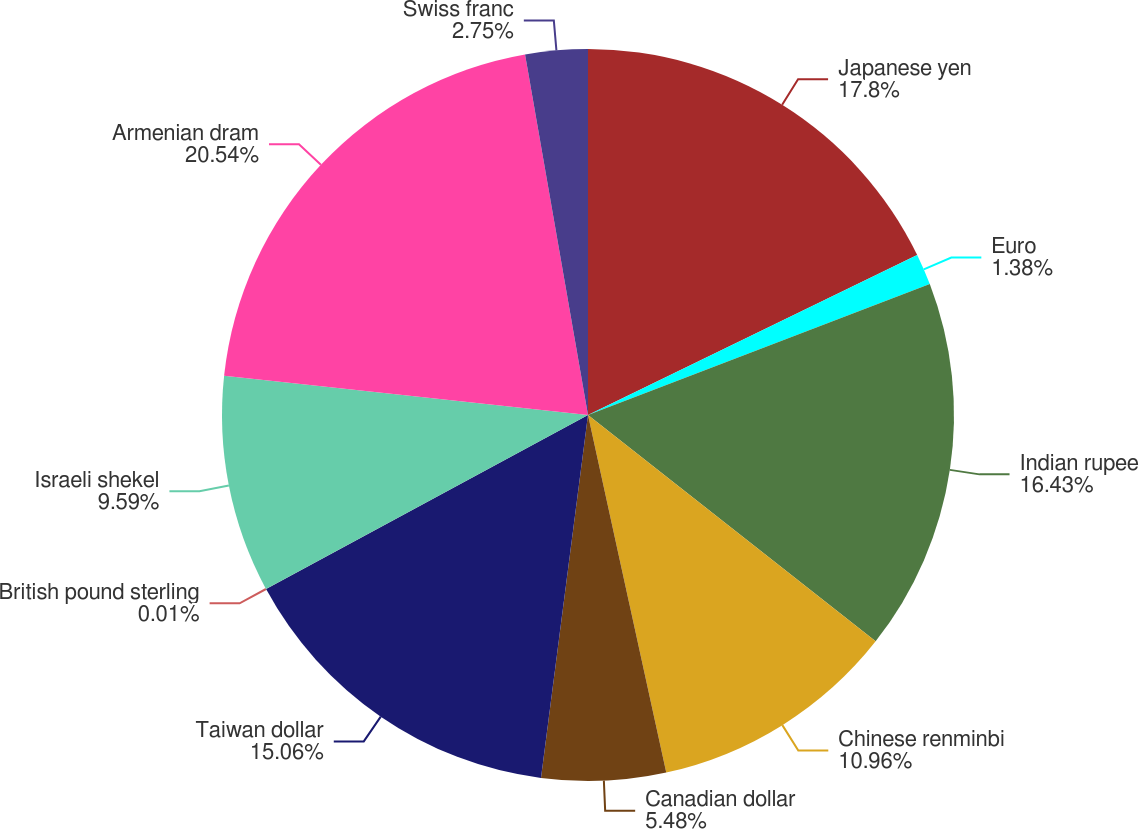Convert chart. <chart><loc_0><loc_0><loc_500><loc_500><pie_chart><fcel>Japanese yen<fcel>Euro<fcel>Indian rupee<fcel>Chinese renminbi<fcel>Canadian dollar<fcel>Taiwan dollar<fcel>British pound sterling<fcel>Israeli shekel<fcel>Armenian dram<fcel>Swiss franc<nl><fcel>17.8%<fcel>1.38%<fcel>16.43%<fcel>10.96%<fcel>5.48%<fcel>15.06%<fcel>0.01%<fcel>9.59%<fcel>20.54%<fcel>2.75%<nl></chart> 